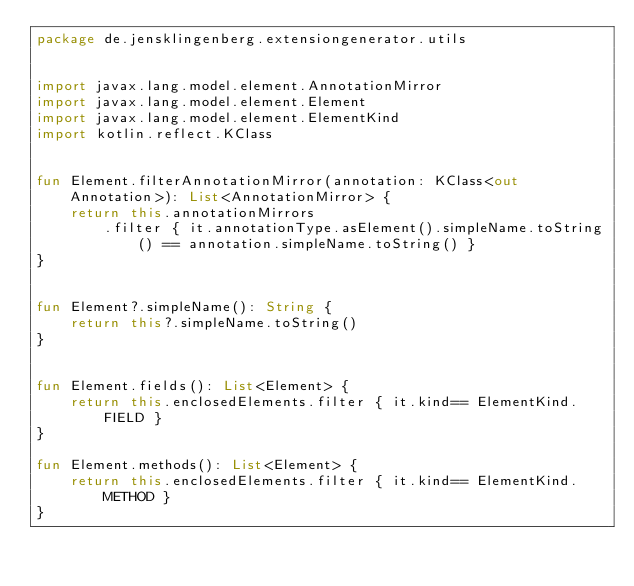Convert code to text. <code><loc_0><loc_0><loc_500><loc_500><_Kotlin_>package de.jensklingenberg.extensiongenerator.utils


import javax.lang.model.element.AnnotationMirror
import javax.lang.model.element.Element
import javax.lang.model.element.ElementKind
import kotlin.reflect.KClass


fun Element.filterAnnotationMirror(annotation: KClass<out Annotation>): List<AnnotationMirror> {
    return this.annotationMirrors
        .filter { it.annotationType.asElement().simpleName.toString() == annotation.simpleName.toString() }
}


fun Element?.simpleName(): String {
    return this?.simpleName.toString()
}


fun Element.fields(): List<Element> {
    return this.enclosedElements.filter { it.kind== ElementKind.FIELD }
}

fun Element.methods(): List<Element> {
    return this.enclosedElements.filter { it.kind== ElementKind.METHOD }
}</code> 